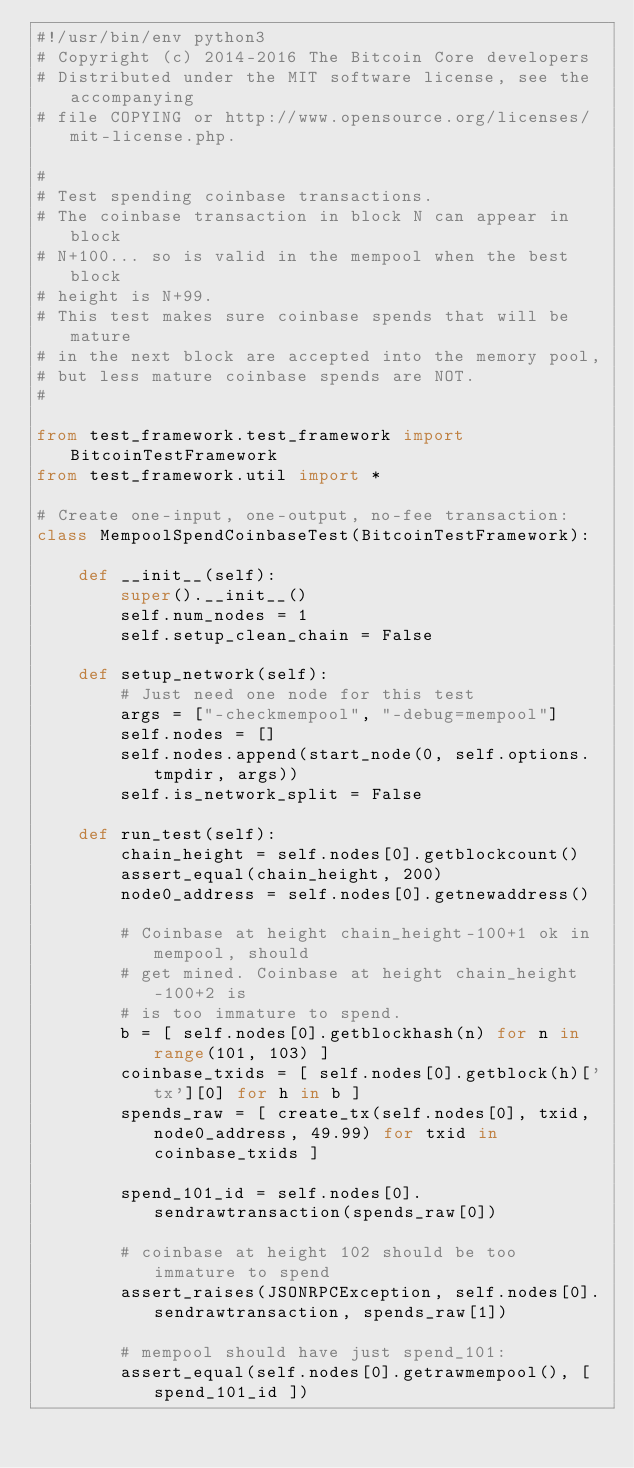Convert code to text. <code><loc_0><loc_0><loc_500><loc_500><_Python_>#!/usr/bin/env python3
# Copyright (c) 2014-2016 The Bitcoin Core developers
# Distributed under the MIT software license, see the accompanying
# file COPYING or http://www.opensource.org/licenses/mit-license.php.

#
# Test spending coinbase transactions.
# The coinbase transaction in block N can appear in block
# N+100... so is valid in the mempool when the best block
# height is N+99.
# This test makes sure coinbase spends that will be mature
# in the next block are accepted into the memory pool,
# but less mature coinbase spends are NOT.
#

from test_framework.test_framework import BitcoinTestFramework
from test_framework.util import *

# Create one-input, one-output, no-fee transaction:
class MempoolSpendCoinbaseTest(BitcoinTestFramework):

    def __init__(self):
        super().__init__()
        self.num_nodes = 1
        self.setup_clean_chain = False

    def setup_network(self):
        # Just need one node for this test
        args = ["-checkmempool", "-debug=mempool"]
        self.nodes = []
        self.nodes.append(start_node(0, self.options.tmpdir, args))
        self.is_network_split = False

    def run_test(self):
        chain_height = self.nodes[0].getblockcount()
        assert_equal(chain_height, 200)
        node0_address = self.nodes[0].getnewaddress()

        # Coinbase at height chain_height-100+1 ok in mempool, should
        # get mined. Coinbase at height chain_height-100+2 is
        # is too immature to spend.
        b = [ self.nodes[0].getblockhash(n) for n in range(101, 103) ]
        coinbase_txids = [ self.nodes[0].getblock(h)['tx'][0] for h in b ]
        spends_raw = [ create_tx(self.nodes[0], txid, node0_address, 49.99) for txid in coinbase_txids ]

        spend_101_id = self.nodes[0].sendrawtransaction(spends_raw[0])

        # coinbase at height 102 should be too immature to spend
        assert_raises(JSONRPCException, self.nodes[0].sendrawtransaction, spends_raw[1])

        # mempool should have just spend_101:
        assert_equal(self.nodes[0].getrawmempool(), [ spend_101_id ])
</code> 